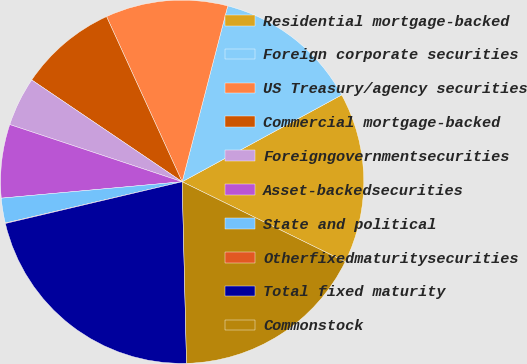Convert chart. <chart><loc_0><loc_0><loc_500><loc_500><pie_chart><fcel>Residential mortgage-backed<fcel>Foreign corporate securities<fcel>US Treasury/agency securities<fcel>Commercial mortgage-backed<fcel>Foreigngovernmentsecurities<fcel>Asset-backedsecurities<fcel>State and political<fcel>Otherfixedmaturitysecurities<fcel>Total fixed maturity<fcel>Commonstock<nl><fcel>15.19%<fcel>13.03%<fcel>10.87%<fcel>8.7%<fcel>4.37%<fcel>6.54%<fcel>2.21%<fcel>0.04%<fcel>21.69%<fcel>17.36%<nl></chart> 